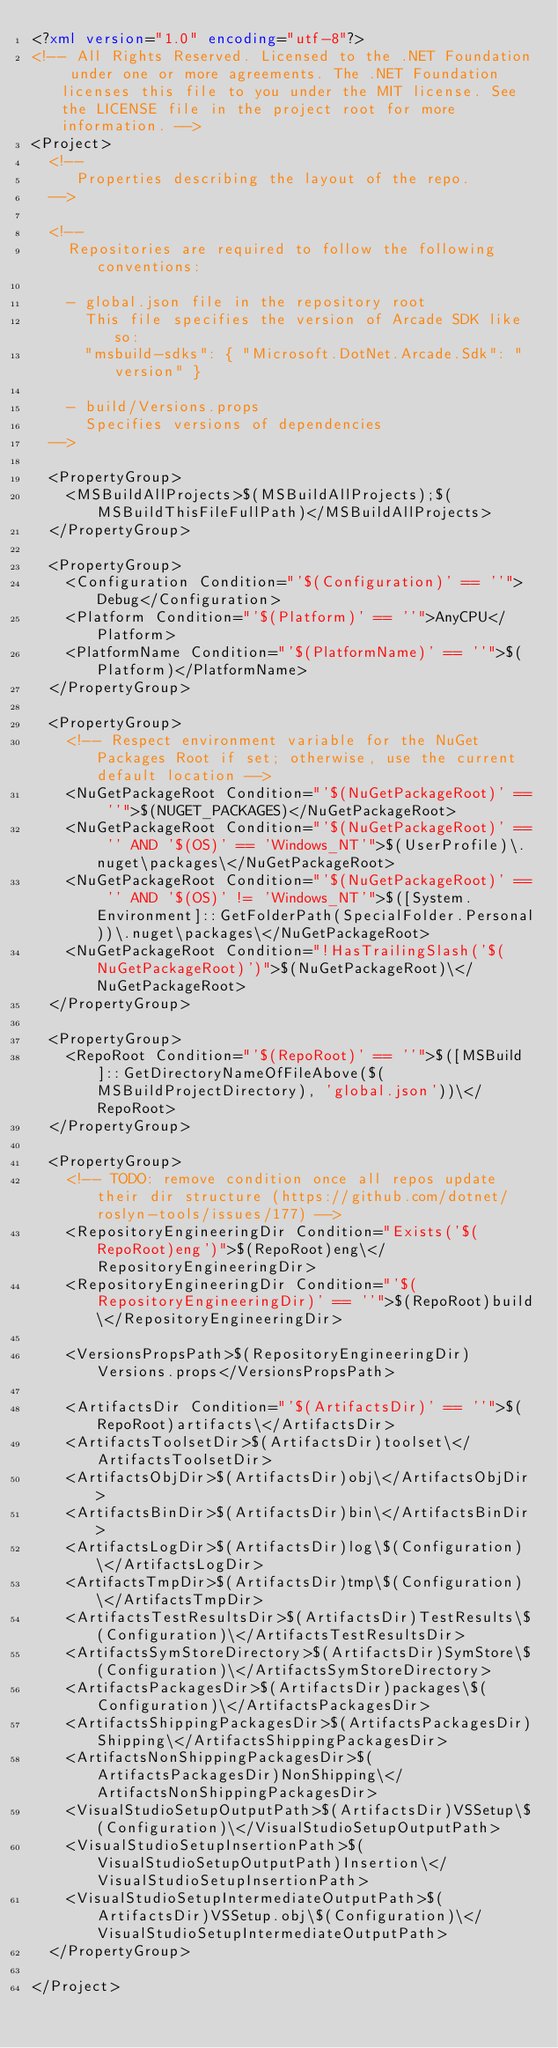<code> <loc_0><loc_0><loc_500><loc_500><_XML_><?xml version="1.0" encoding="utf-8"?>
<!-- All Rights Reserved. Licensed to the .NET Foundation under one or more agreements. The .NET Foundation licenses this file to you under the MIT license. See the LICENSE file in the project root for more information. -->
<Project>
  <!--
     Properties describing the layout of the repo.
  -->

  <!-- 
    Repositories are required to follow the following conventions:
      
    - global.json file in the repository root
      This file specifies the version of Arcade SDK like so:
      "msbuild-sdks": { "Microsoft.DotNet.Arcade.Sdk": "version" }
      
    - build/Versions.props 
      Specifies versions of dependencies
  -->

  <PropertyGroup>
    <MSBuildAllProjects>$(MSBuildAllProjects);$(MSBuildThisFileFullPath)</MSBuildAllProjects>
  </PropertyGroup>

  <PropertyGroup>
    <Configuration Condition="'$(Configuration)' == ''">Debug</Configuration>
    <Platform Condition="'$(Platform)' == ''">AnyCPU</Platform>
    <PlatformName Condition="'$(PlatformName)' == ''">$(Platform)</PlatformName>
  </PropertyGroup>

  <PropertyGroup>
    <!-- Respect environment variable for the NuGet Packages Root if set; otherwise, use the current default location -->
    <NuGetPackageRoot Condition="'$(NuGetPackageRoot)' == ''">$(NUGET_PACKAGES)</NuGetPackageRoot>
    <NuGetPackageRoot Condition="'$(NuGetPackageRoot)' == '' AND '$(OS)' == 'Windows_NT'">$(UserProfile)\.nuget\packages\</NuGetPackageRoot>
    <NuGetPackageRoot Condition="'$(NuGetPackageRoot)' == '' AND '$(OS)' != 'Windows_NT'">$([System.Environment]::GetFolderPath(SpecialFolder.Personal))\.nuget\packages\</NuGetPackageRoot>
    <NuGetPackageRoot Condition="!HasTrailingSlash('$(NuGetPackageRoot)')">$(NuGetPackageRoot)\</NuGetPackageRoot>
  </PropertyGroup>

  <PropertyGroup>
    <RepoRoot Condition="'$(RepoRoot)' == ''">$([MSBuild]::GetDirectoryNameOfFileAbove($(MSBuildProjectDirectory), 'global.json'))\</RepoRoot>
  </PropertyGroup>

  <PropertyGroup>
    <!-- TODO: remove condition once all repos update their dir structure (https://github.com/dotnet/roslyn-tools/issues/177) -->
    <RepositoryEngineeringDir Condition="Exists('$(RepoRoot)eng')">$(RepoRoot)eng\</RepositoryEngineeringDir>
    <RepositoryEngineeringDir Condition="'$(RepositoryEngineeringDir)' == ''">$(RepoRoot)build\</RepositoryEngineeringDir>

    <VersionsPropsPath>$(RepositoryEngineeringDir)Versions.props</VersionsPropsPath>

    <ArtifactsDir Condition="'$(ArtifactsDir)' == ''">$(RepoRoot)artifacts\</ArtifactsDir>
    <ArtifactsToolsetDir>$(ArtifactsDir)toolset\</ArtifactsToolsetDir>
    <ArtifactsObjDir>$(ArtifactsDir)obj\</ArtifactsObjDir>
    <ArtifactsBinDir>$(ArtifactsDir)bin\</ArtifactsBinDir>
    <ArtifactsLogDir>$(ArtifactsDir)log\$(Configuration)\</ArtifactsLogDir>
    <ArtifactsTmpDir>$(ArtifactsDir)tmp\$(Configuration)\</ArtifactsTmpDir>
    <ArtifactsTestResultsDir>$(ArtifactsDir)TestResults\$(Configuration)\</ArtifactsTestResultsDir>
    <ArtifactsSymStoreDirectory>$(ArtifactsDir)SymStore\$(Configuration)\</ArtifactsSymStoreDirectory>
    <ArtifactsPackagesDir>$(ArtifactsDir)packages\$(Configuration)\</ArtifactsPackagesDir>
    <ArtifactsShippingPackagesDir>$(ArtifactsPackagesDir)Shipping\</ArtifactsShippingPackagesDir>
    <ArtifactsNonShippingPackagesDir>$(ArtifactsPackagesDir)NonShipping\</ArtifactsNonShippingPackagesDir>
    <VisualStudioSetupOutputPath>$(ArtifactsDir)VSSetup\$(Configuration)\</VisualStudioSetupOutputPath>
    <VisualStudioSetupInsertionPath>$(VisualStudioSetupOutputPath)Insertion\</VisualStudioSetupInsertionPath>
    <VisualStudioSetupIntermediateOutputPath>$(ArtifactsDir)VSSetup.obj\$(Configuration)\</VisualStudioSetupIntermediateOutputPath>
  </PropertyGroup>

</Project>
</code> 